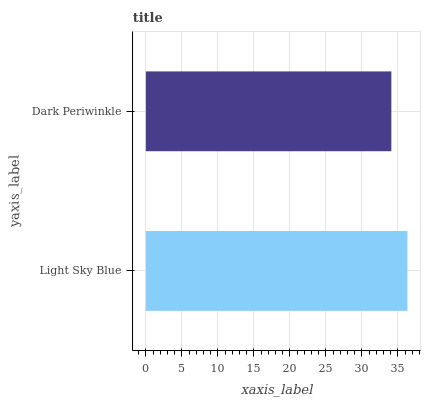Is Dark Periwinkle the minimum?
Answer yes or no. Yes. Is Light Sky Blue the maximum?
Answer yes or no. Yes. Is Dark Periwinkle the maximum?
Answer yes or no. No. Is Light Sky Blue greater than Dark Periwinkle?
Answer yes or no. Yes. Is Dark Periwinkle less than Light Sky Blue?
Answer yes or no. Yes. Is Dark Periwinkle greater than Light Sky Blue?
Answer yes or no. No. Is Light Sky Blue less than Dark Periwinkle?
Answer yes or no. No. Is Light Sky Blue the high median?
Answer yes or no. Yes. Is Dark Periwinkle the low median?
Answer yes or no. Yes. Is Dark Periwinkle the high median?
Answer yes or no. No. Is Light Sky Blue the low median?
Answer yes or no. No. 